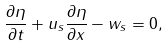<formula> <loc_0><loc_0><loc_500><loc_500>\frac { \partial \eta } { \partial t } + u _ { s } \frac { \partial \eta } { \partial x } - w _ { s } = 0 ,</formula> 